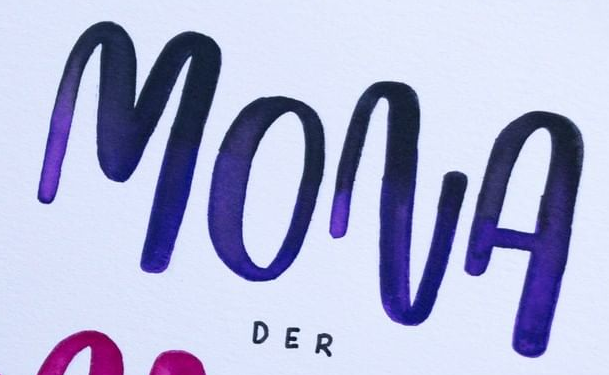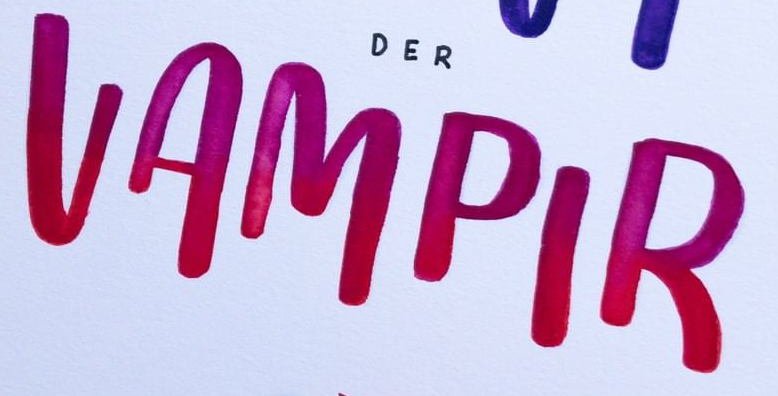Read the text from these images in sequence, separated by a semicolon. MONA; VAMPIR 